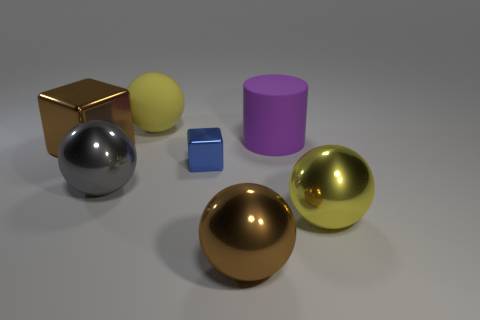Subtract all gray metal spheres. How many spheres are left? 3 Add 2 purple metallic objects. How many objects exist? 9 Subtract all yellow cylinders. How many yellow balls are left? 2 Subtract all balls. How many objects are left? 3 Subtract all yellow spheres. How many spheres are left? 2 Subtract 0 cyan spheres. How many objects are left? 7 Subtract 2 spheres. How many spheres are left? 2 Subtract all gray cubes. Subtract all red cylinders. How many cubes are left? 2 Subtract all brown metal objects. Subtract all big gray shiny spheres. How many objects are left? 4 Add 5 large brown things. How many large brown things are left? 7 